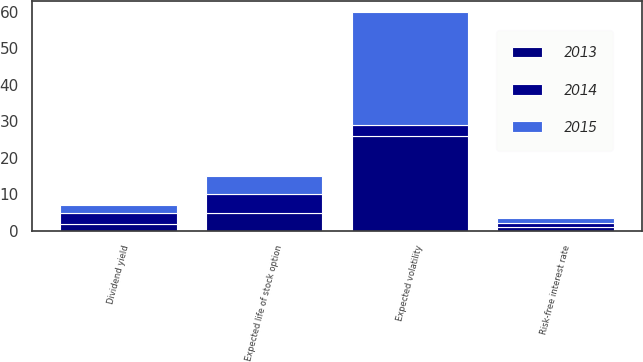Convert chart. <chart><loc_0><loc_0><loc_500><loc_500><stacked_bar_chart><ecel><fcel>Dividend yield<fcel>Expected volatility<fcel>Risk-free interest rate<fcel>Expected life of stock option<nl><fcel>2013<fcel>2<fcel>26<fcel>1.2<fcel>5<nl><fcel>2015<fcel>2<fcel>31<fcel>1.5<fcel>5<nl><fcel>2014<fcel>3<fcel>3<fcel>0.9<fcel>5<nl></chart> 